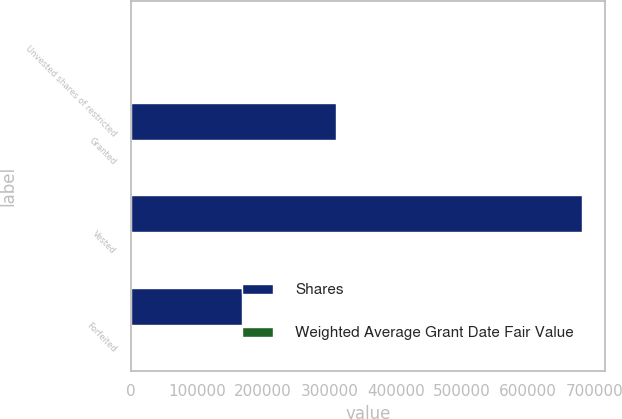Convert chart to OTSL. <chart><loc_0><loc_0><loc_500><loc_500><stacked_bar_chart><ecel><fcel>Unvested shares of restricted<fcel>Granted<fcel>Vested<fcel>Forfeited<nl><fcel>Shares<fcel>60<fcel>309526<fcel>681699<fcel>168661<nl><fcel>Weighted Average Grant Date Fair Value<fcel>20.56<fcel>60<fcel>6.67<fcel>35.2<nl></chart> 